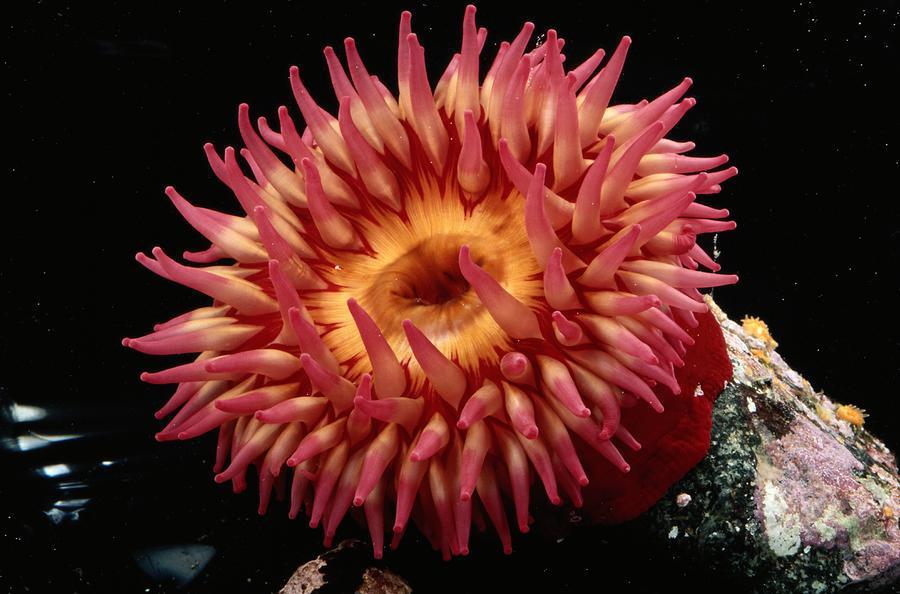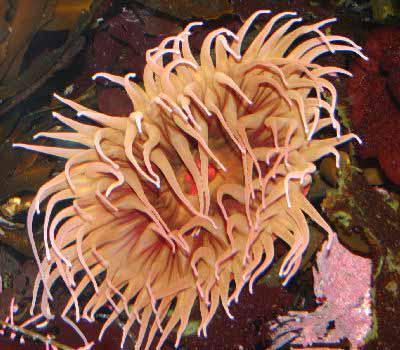The first image is the image on the left, the second image is the image on the right. Evaluate the accuracy of this statement regarding the images: "Another creature is amongst the coral.". Is it true? Answer yes or no. No. 